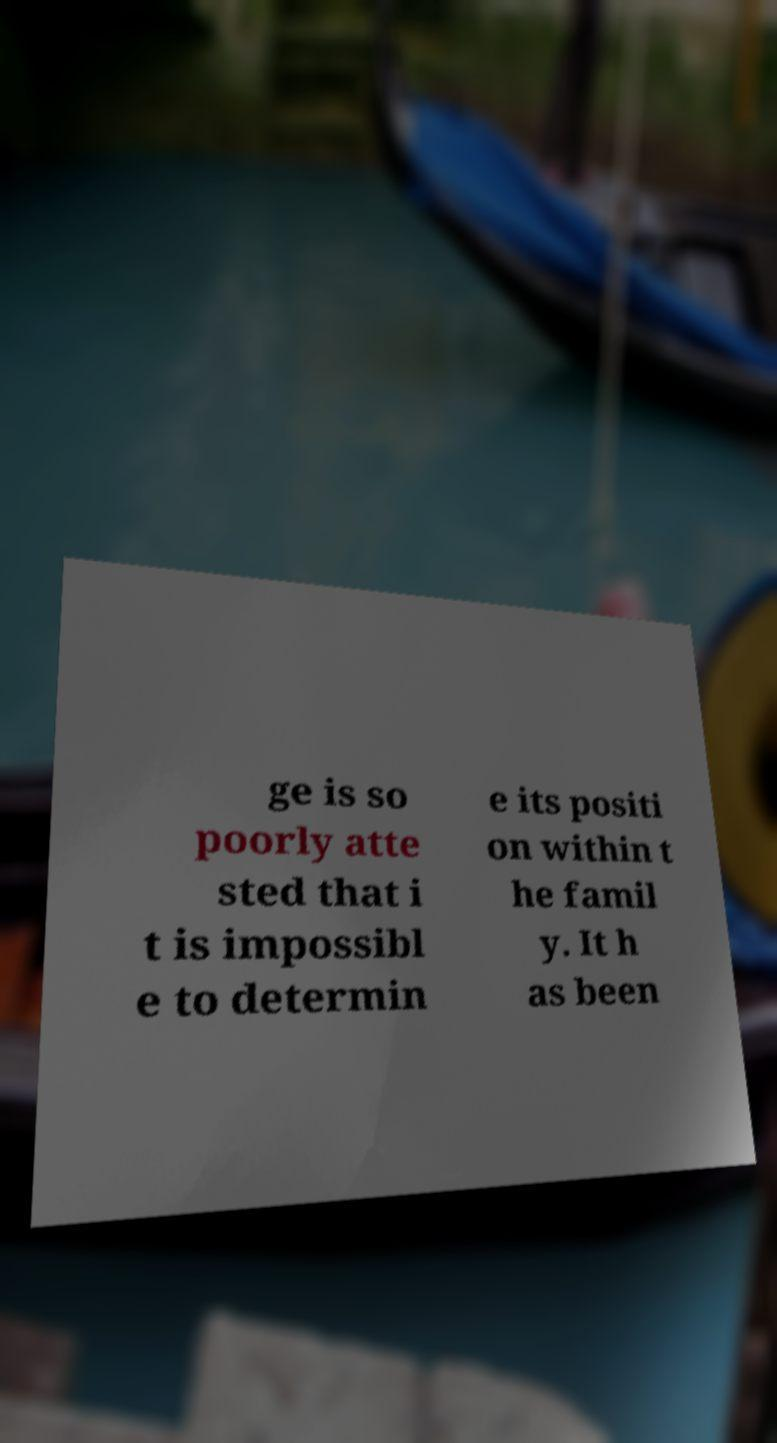What messages or text are displayed in this image? I need them in a readable, typed format. ge is so poorly atte sted that i t is impossibl e to determin e its positi on within t he famil y. It h as been 